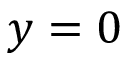Convert formula to latex. <formula><loc_0><loc_0><loc_500><loc_500>y = 0</formula> 